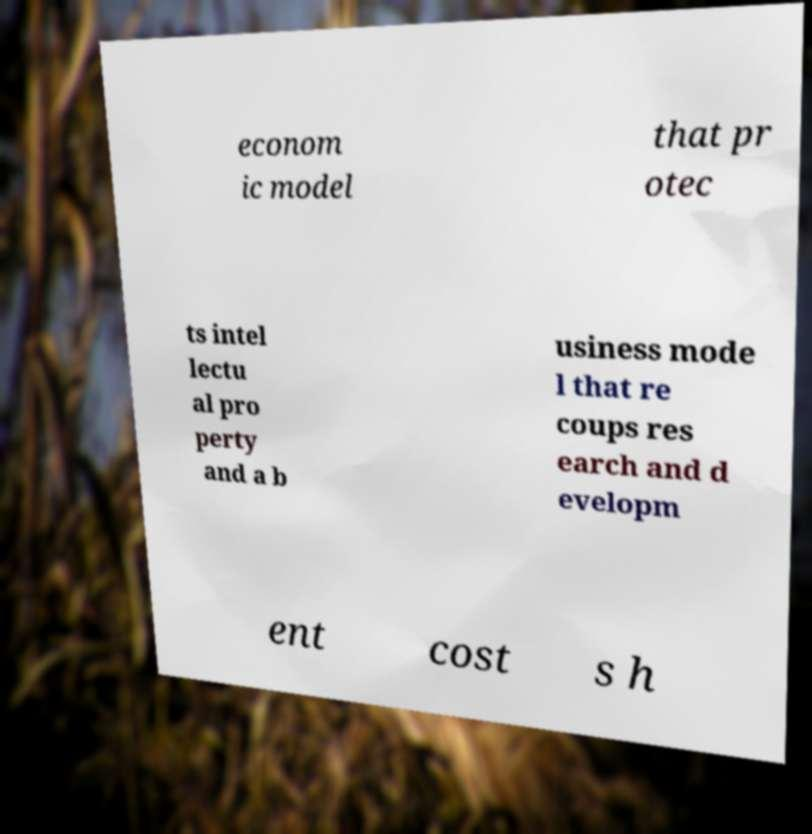There's text embedded in this image that I need extracted. Can you transcribe it verbatim? econom ic model that pr otec ts intel lectu al pro perty and a b usiness mode l that re coups res earch and d evelopm ent cost s h 